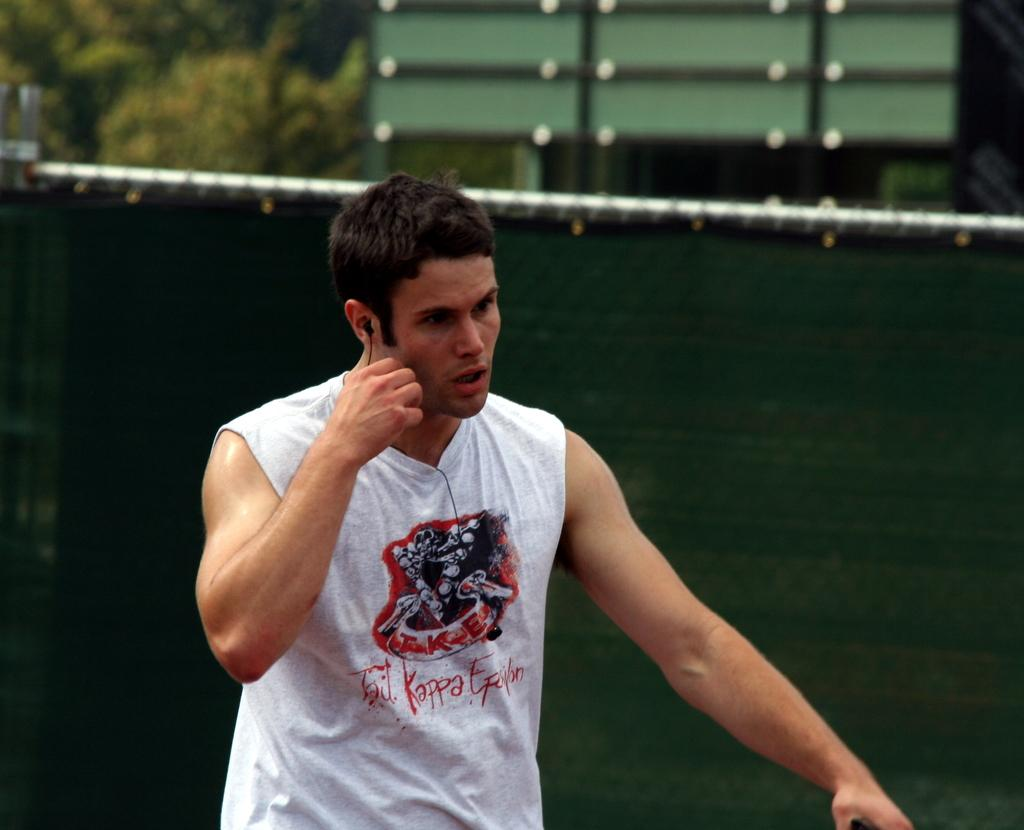<image>
Create a compact narrative representing the image presented. A man wearing earbuds an a Tau Kappa Epsilon shirt. 